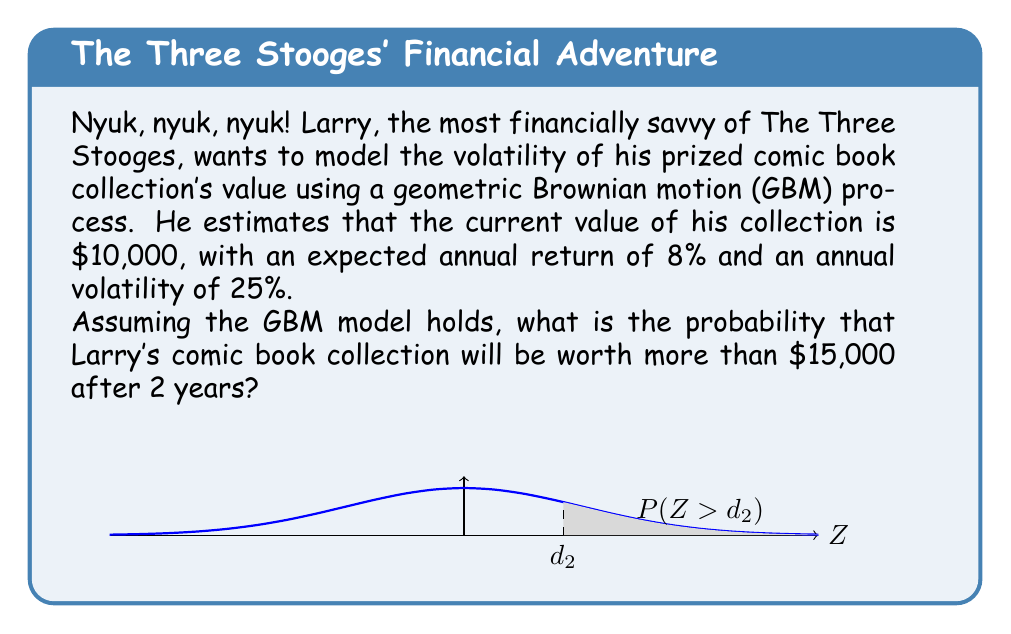Help me with this question. Let's approach this step-by-step using the Black-Scholes-Merton framework:

1) We're using a Geometric Brownian Motion (GBM) model, which assumes that the logarithm of the asset price follows a Brownian motion with drift.

2) The formula for the probability that a GBM process $S_t$ exceeds a certain value $K$ at time $T$ is:

   $$P(S_T > K) = N(d_2)$$

   where $N(\cdot)$ is the cumulative standard normal distribution function, and

   $$d_2 = \frac{\ln(\frac{S_0}{K}) + (\mu - \frac{\sigma^2}{2})T}{\sigma\sqrt{T}}$$

3) Given:
   - Initial value $S_0 = \$10,000$
   - Target value $K = \$15,000$
   - Time $T = 2$ years
   - Expected annual return $\mu = 8\% = 0.08$
   - Annual volatility $\sigma = 25\% = 0.25$

4) Let's calculate $d_2$:

   $$d_2 = \frac{\ln(\frac{10000}{15000}) + (0.08 - \frac{0.25^2}{2})2}{0.25\sqrt{2}}$$

5) Simplify:
   $$d_2 = \frac{\ln(0.6667) + (0.08 - 0.03125)2}{0.25\sqrt{2}}$$
   $$d_2 = \frac{-0.4055 + 0.09750}{0.3536}$$
   $$d_2 = -0.8710$$

6) Now we need to find $N(-0.8710)$. Using a standard normal distribution table or calculator:

   $$N(-0.8710) \approx 0.1919$$

7) Therefore, the probability that Larry's comic book collection will be worth more than $15,000 after 2 years is:

   $$P(S_2 > 15000) = 1 - N(-0.8710) = 1 - 0.1919 = 0.8081$$
Answer: 80.81% 